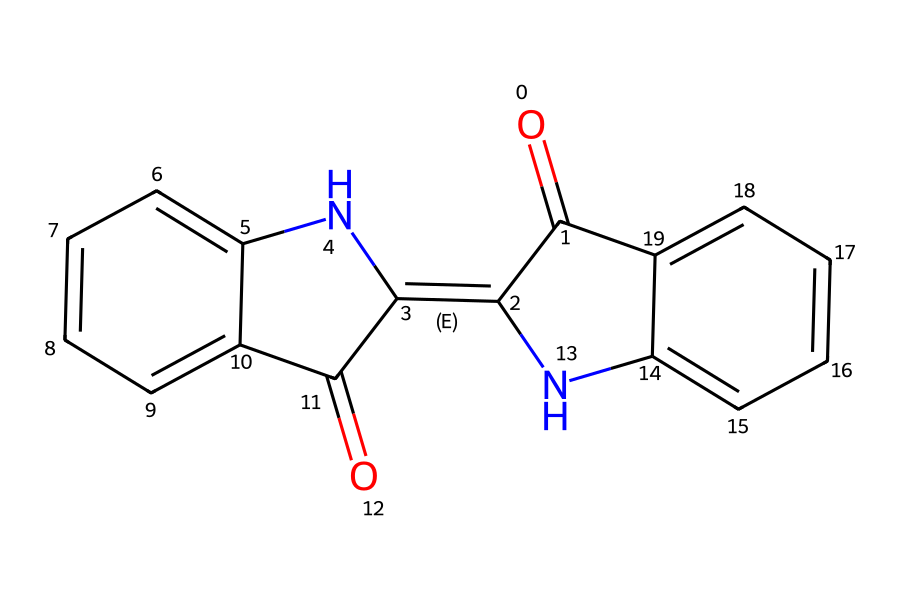What is the molecular formula of this chemical? To determine the molecular formula, count the number of each type of atom in the chemical structure. In the provided SMILES, there are 15 carbon atoms, 9 hydrogen atoms, 4 oxygen atoms, and 2 nitrogen atoms. Therefore, the molecular formula is C15H9N2O4.
Answer: C15H9N2O4 How many rings are present in this chemical structure? By analyzing the chemical structure encoded in the SMILES, observe the cyclic components. The structure contains 3 interconnected rings, which can be counted from the notations in the SMILES that indicate ring connections.
Answer: 3 What type of chemical bonding is primarily featured in this compound? The chemical structure reveals multiple double bonds (indicated by "=" in the SMILES) and single bonds. The presence of conjugated double bonds suggests that this compound primarily exhibits covalent bonding.
Answer: covalent Is this chemical an acid or a base? Examine the functional groups present within the chemical structure. Since there are no groups indicative of basicity (like amines) or strong acidity (such as carboxylic acids), the overall nature leans toward being an acid, particularly due to the carbonyl group.
Answer: acid Which elements present in this chemical contribute to its color properties? The color of natural dyes often arises from the presence of conjugated systems and certain functional groups. In this structure, the presence of conjugated double bonds (from the aromatic rings) contributes significantly to its color.
Answer: nitrogen and carbon 